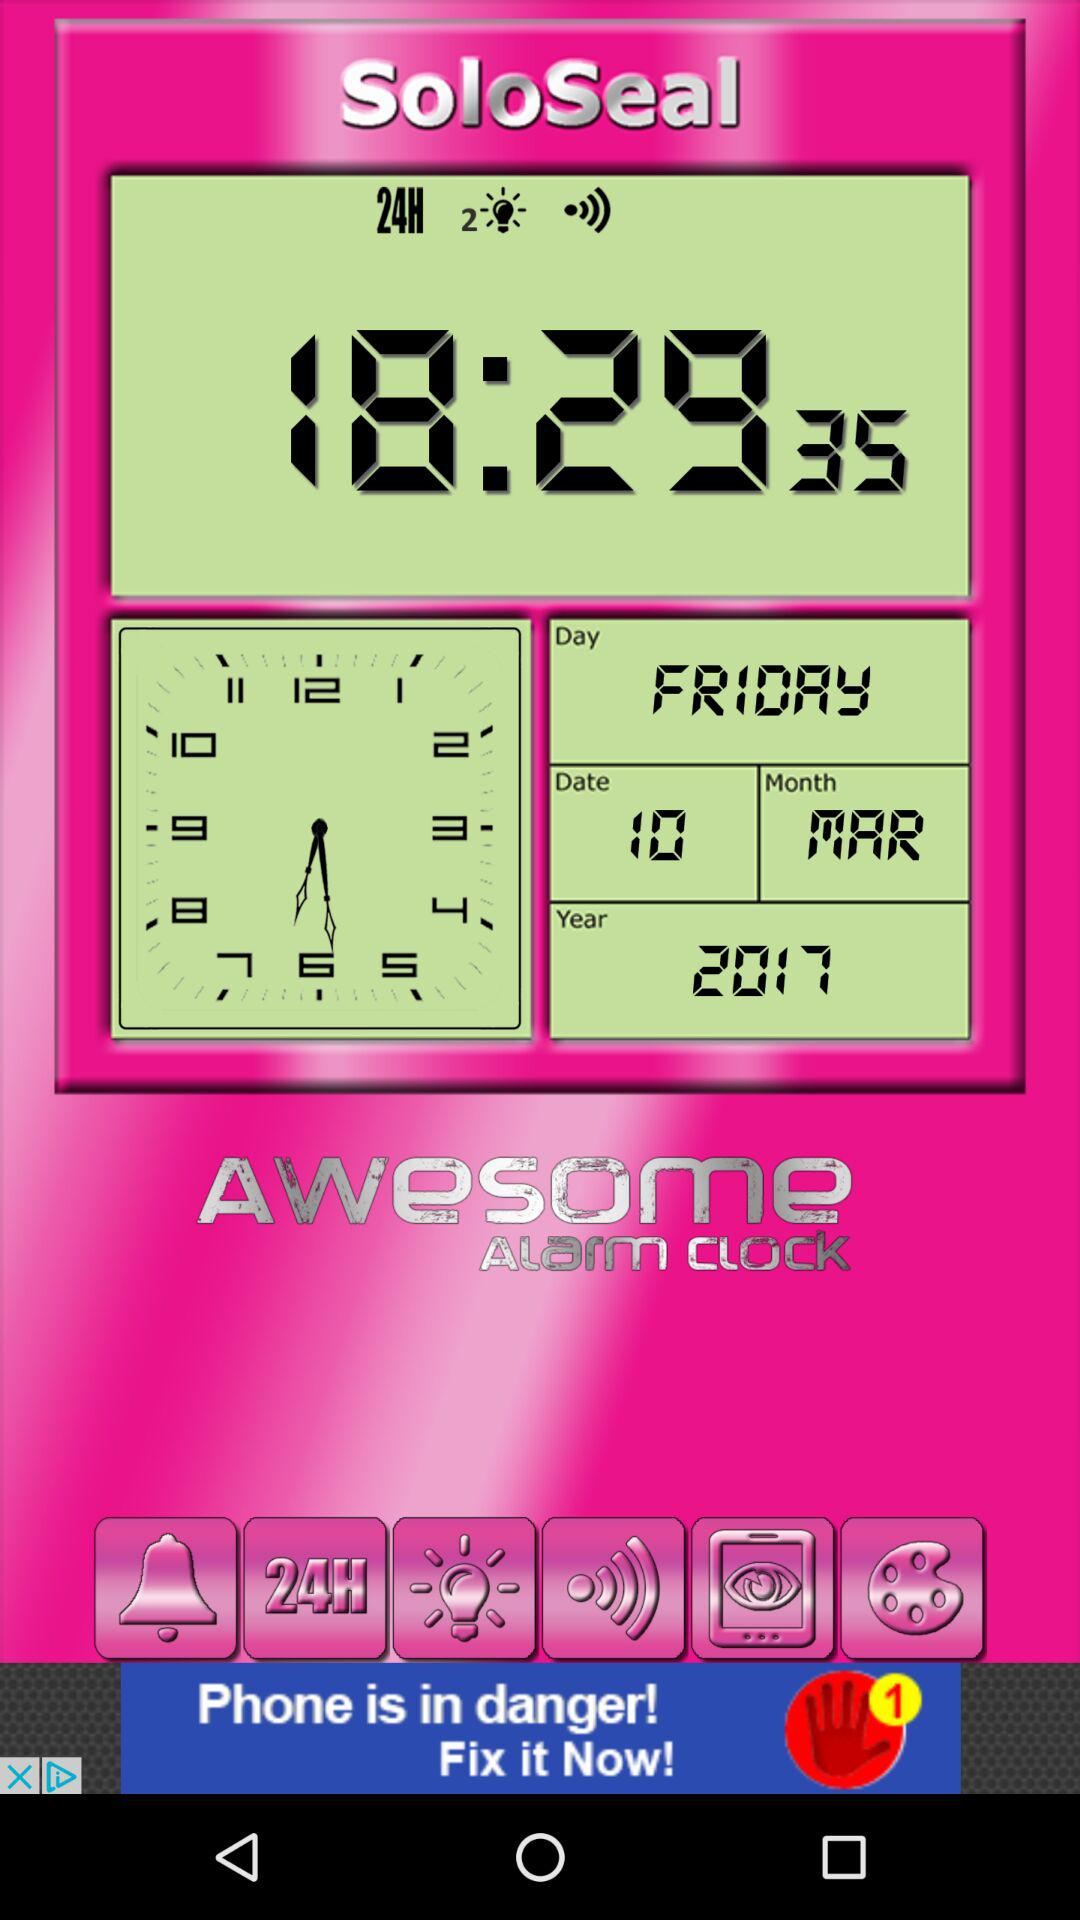Which day is selected? The selected day is Friday. 